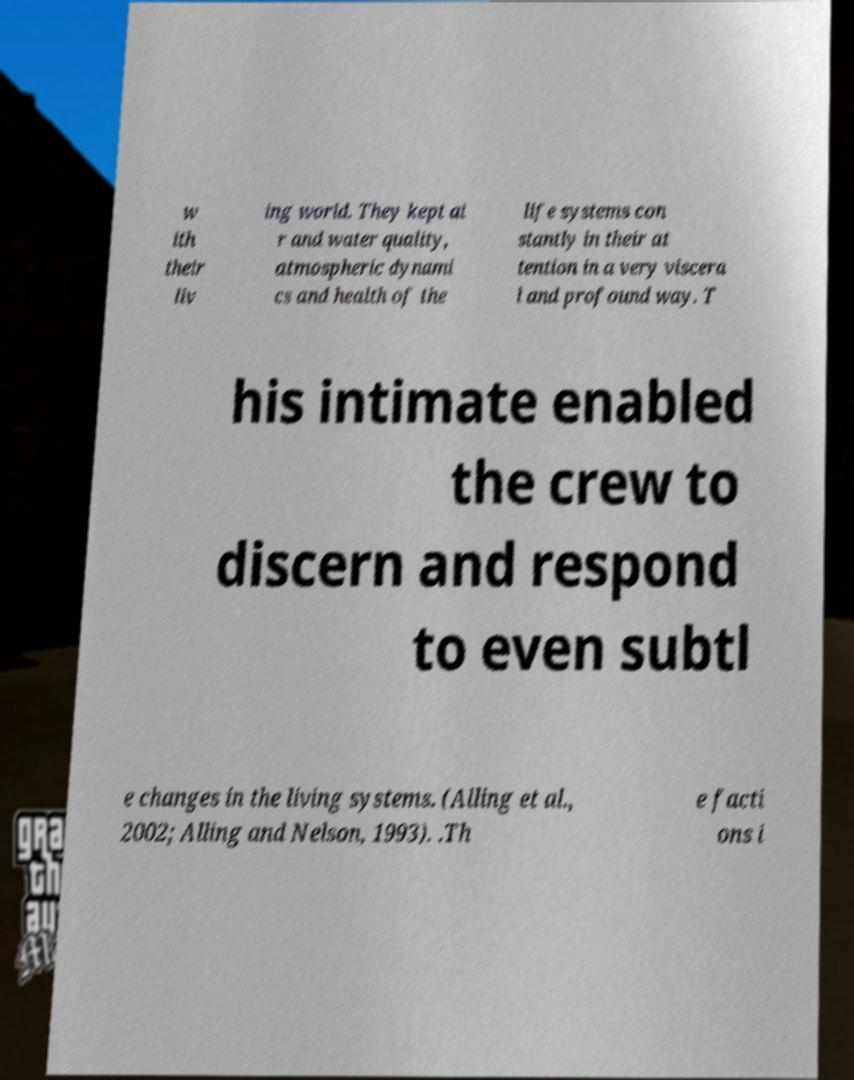There's text embedded in this image that I need extracted. Can you transcribe it verbatim? w ith their liv ing world. They kept ai r and water quality, atmospheric dynami cs and health of the life systems con stantly in their at tention in a very viscera l and profound way. T his intimate enabled the crew to discern and respond to even subtl e changes in the living systems. (Alling et al., 2002; Alling and Nelson, 1993). .Th e facti ons i 